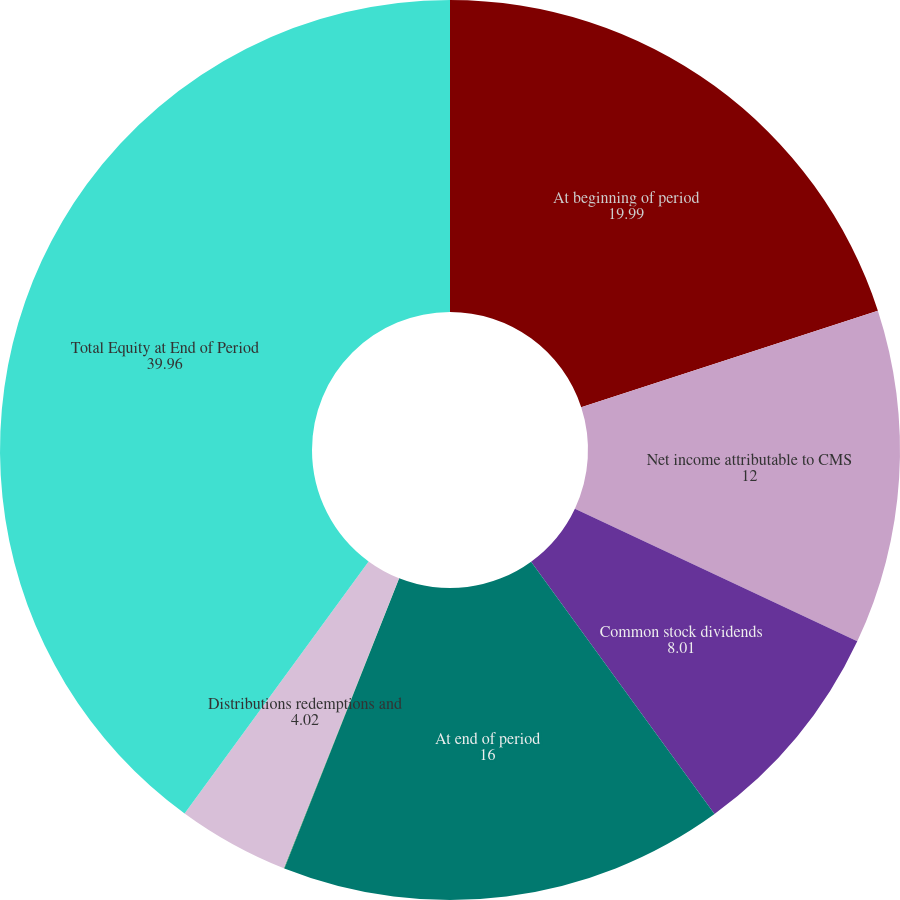<chart> <loc_0><loc_0><loc_500><loc_500><pie_chart><fcel>At beginning of period<fcel>Net income attributable to CMS<fcel>Common stock dividends<fcel>At end of period<fcel>Income attributable to<fcel>Distributions redemptions and<fcel>Total Equity at End of Period<nl><fcel>19.99%<fcel>12.0%<fcel>8.01%<fcel>16.0%<fcel>0.02%<fcel>4.02%<fcel>39.96%<nl></chart> 